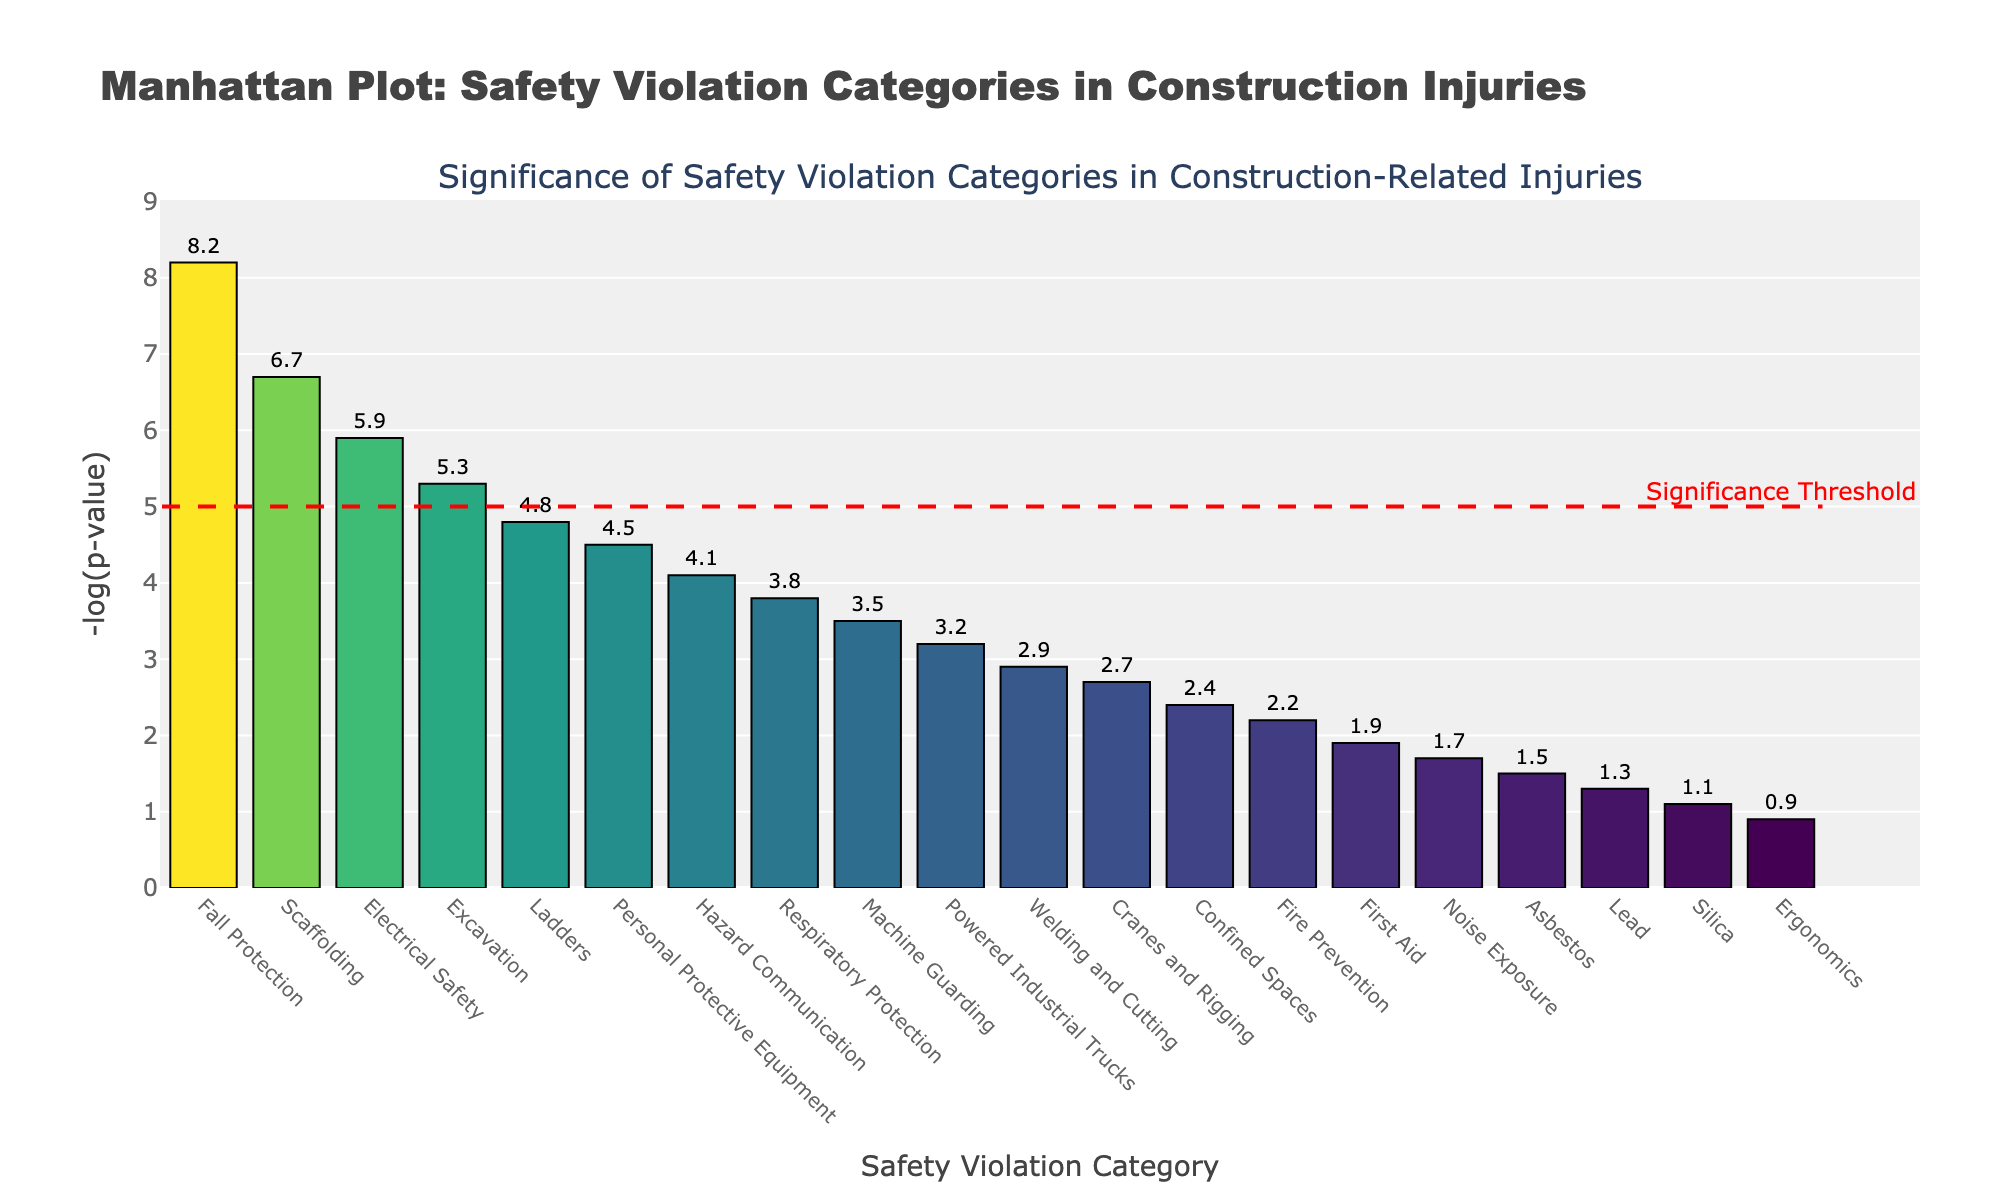what is the title of the plot? The title is located at the top of the figure and is descriptive of the data shown.
Answer: Manhattan Plot: Safety Violation Categories in Construction Injuries how many categories have a -log(p-value) greater than or equal to 5? Count the bars that have a -log(p-value) value of 5 or greater.
Answer: 4 which safety violation category is the most significant? The most significant category will have the highest -log(p-value) value, which is indicated by the tallest bar.
Answer: Fall Protection Are "Respiratory Protection" and "Machine Guarding" above or below the significance threshold? Check the heights of the bars for these categories and compare them to the red dashed significance line at -log(p-value) = 5.
Answer: Both are below what is the approximate -log(p-value) for welding and cutting? Look for the bar labeled "Welding and Cutting" and read the value given above or beside it.
Answer: 2.9 How does the significance of "Excavation" compare to "Ladders"? Compare the heights of the bars for these two categories.
Answer: Excavation is more significant than Ladders What is indicated by the red dashed line in the plot? This line marks a specific threshold and is labeled within the figure.
Answer: Significance Threshold Which categories are the least significant, falling below a -log(p-value) of 2? Identify the bars that do not reach the height of 2 on the y-axis.
Answer: First Aid, Noise Exposure, Asbestos, Lead, Silica, Ergonomics if we combine the -log(p-value) values of “Scaffolding” and “Electrical Safety”, what is the sum? Find the individual values for these categories and add them together: 6.7 + 5.9.
Answer: 12.6 is there a clear visual difference between the significance of “Powered Industrial Trucks” and “Cranes and Rigging”? Compare the heights and colors of these two bars to see if there is a marked difference.
Answer: No 